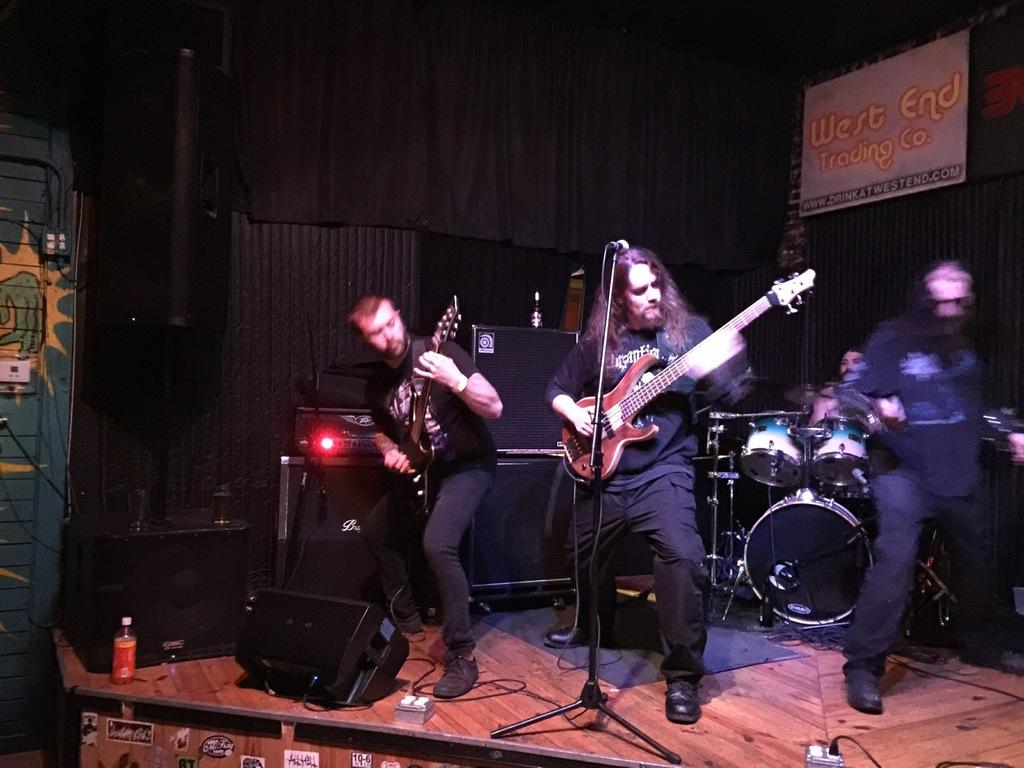What type of event is depicted in the image? The image is from a musical concert. What are the people in the image doing? There are people playing musical instruments in the image. What else can be seen in the image besides the musicians? There are wires visible in the image. Can you identify any other objects in the image? Yes, there is a bottle in the image. What type of authority is present in the image? There is no specific authority figure present in the image; it depicts a musical concert with musicians playing instruments. Can you describe the structure of the building in the image? There is no building structure visible in the image; it primarily focuses on the musicians and their instruments. 